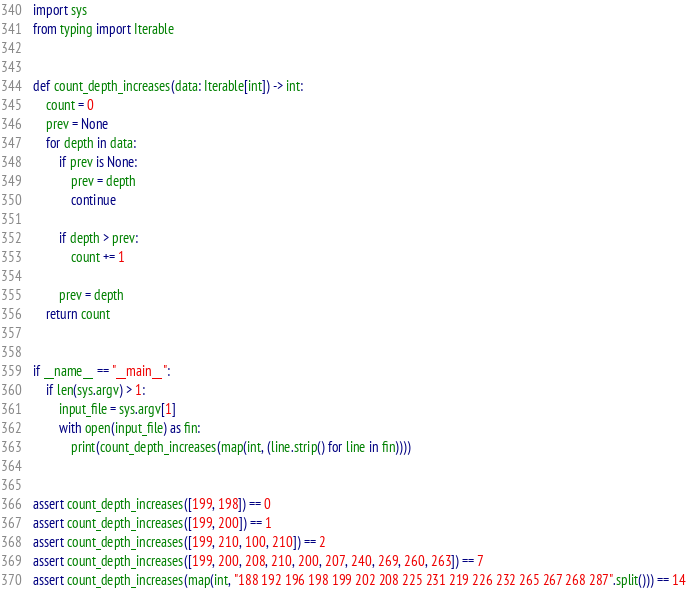<code> <loc_0><loc_0><loc_500><loc_500><_Python_>import sys
from typing import Iterable


def count_depth_increases(data: Iterable[int]) -> int:
    count = 0
    prev = None
    for depth in data:
        if prev is None:
            prev = depth
            continue

        if depth > prev:
            count += 1

        prev = depth
    return count


if __name__ == "__main__":
    if len(sys.argv) > 1:
        input_file = sys.argv[1]
        with open(input_file) as fin:
            print(count_depth_increases(map(int, (line.strip() for line in fin))))


assert count_depth_increases([199, 198]) == 0
assert count_depth_increases([199, 200]) == 1
assert count_depth_increases([199, 210, 100, 210]) == 2
assert count_depth_increases([199, 200, 208, 210, 200, 207, 240, 269, 260, 263]) == 7
assert count_depth_increases(map(int, "188 192 196 198 199 202 208 225 231 219 226 232 265 267 268 287".split())) == 14
</code> 